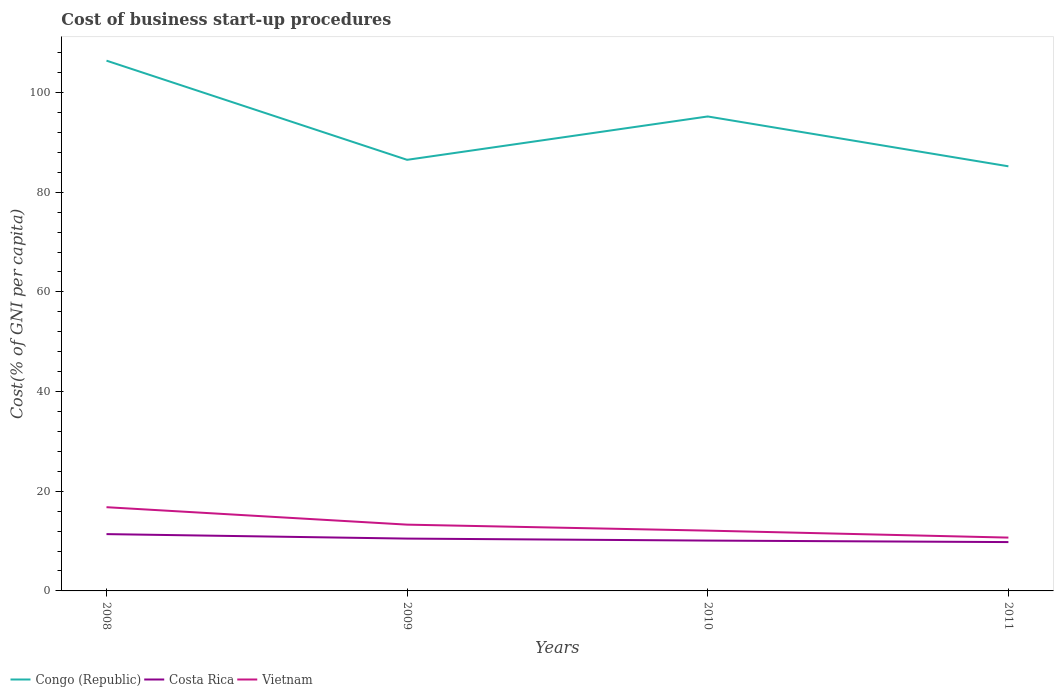Is the number of lines equal to the number of legend labels?
Provide a short and direct response. Yes. Across all years, what is the maximum cost of business start-up procedures in Congo (Republic)?
Provide a short and direct response. 85.2. In which year was the cost of business start-up procedures in Costa Rica maximum?
Ensure brevity in your answer.  2011. What is the total cost of business start-up procedures in Congo (Republic) in the graph?
Keep it short and to the point. 10. What is the difference between the highest and the second highest cost of business start-up procedures in Congo (Republic)?
Provide a succinct answer. 21.2. What is the difference between the highest and the lowest cost of business start-up procedures in Costa Rica?
Provide a short and direct response. 2. Is the cost of business start-up procedures in Vietnam strictly greater than the cost of business start-up procedures in Congo (Republic) over the years?
Your response must be concise. Yes. Are the values on the major ticks of Y-axis written in scientific E-notation?
Your response must be concise. No. Does the graph contain any zero values?
Your answer should be compact. No. How many legend labels are there?
Offer a terse response. 3. How are the legend labels stacked?
Your answer should be very brief. Horizontal. What is the title of the graph?
Offer a very short reply. Cost of business start-up procedures. Does "East Asia (developing only)" appear as one of the legend labels in the graph?
Ensure brevity in your answer.  No. What is the label or title of the X-axis?
Ensure brevity in your answer.  Years. What is the label or title of the Y-axis?
Offer a very short reply. Cost(% of GNI per capita). What is the Cost(% of GNI per capita) in Congo (Republic) in 2008?
Keep it short and to the point. 106.4. What is the Cost(% of GNI per capita) of Congo (Republic) in 2009?
Your answer should be very brief. 86.5. What is the Cost(% of GNI per capita) of Vietnam in 2009?
Your response must be concise. 13.3. What is the Cost(% of GNI per capita) of Congo (Republic) in 2010?
Ensure brevity in your answer.  95.2. What is the Cost(% of GNI per capita) of Congo (Republic) in 2011?
Provide a short and direct response. 85.2. Across all years, what is the maximum Cost(% of GNI per capita) of Congo (Republic)?
Offer a terse response. 106.4. Across all years, what is the maximum Cost(% of GNI per capita) of Vietnam?
Your response must be concise. 16.8. Across all years, what is the minimum Cost(% of GNI per capita) of Congo (Republic)?
Provide a succinct answer. 85.2. Across all years, what is the minimum Cost(% of GNI per capita) in Costa Rica?
Provide a succinct answer. 9.8. What is the total Cost(% of GNI per capita) in Congo (Republic) in the graph?
Ensure brevity in your answer.  373.3. What is the total Cost(% of GNI per capita) of Costa Rica in the graph?
Your answer should be very brief. 41.8. What is the total Cost(% of GNI per capita) of Vietnam in the graph?
Keep it short and to the point. 52.9. What is the difference between the Cost(% of GNI per capita) of Vietnam in 2008 and that in 2009?
Make the answer very short. 3.5. What is the difference between the Cost(% of GNI per capita) of Costa Rica in 2008 and that in 2010?
Give a very brief answer. 1.3. What is the difference between the Cost(% of GNI per capita) in Congo (Republic) in 2008 and that in 2011?
Ensure brevity in your answer.  21.2. What is the difference between the Cost(% of GNI per capita) in Vietnam in 2008 and that in 2011?
Ensure brevity in your answer.  6.1. What is the difference between the Cost(% of GNI per capita) in Costa Rica in 2009 and that in 2010?
Ensure brevity in your answer.  0.4. What is the difference between the Cost(% of GNI per capita) of Vietnam in 2009 and that in 2010?
Give a very brief answer. 1.2. What is the difference between the Cost(% of GNI per capita) of Congo (Republic) in 2009 and that in 2011?
Provide a succinct answer. 1.3. What is the difference between the Cost(% of GNI per capita) in Costa Rica in 2009 and that in 2011?
Ensure brevity in your answer.  0.7. What is the difference between the Cost(% of GNI per capita) of Congo (Republic) in 2010 and that in 2011?
Keep it short and to the point. 10. What is the difference between the Cost(% of GNI per capita) of Congo (Republic) in 2008 and the Cost(% of GNI per capita) of Costa Rica in 2009?
Provide a short and direct response. 95.9. What is the difference between the Cost(% of GNI per capita) of Congo (Republic) in 2008 and the Cost(% of GNI per capita) of Vietnam in 2009?
Give a very brief answer. 93.1. What is the difference between the Cost(% of GNI per capita) of Congo (Republic) in 2008 and the Cost(% of GNI per capita) of Costa Rica in 2010?
Your answer should be compact. 96.3. What is the difference between the Cost(% of GNI per capita) of Congo (Republic) in 2008 and the Cost(% of GNI per capita) of Vietnam in 2010?
Provide a succinct answer. 94.3. What is the difference between the Cost(% of GNI per capita) of Costa Rica in 2008 and the Cost(% of GNI per capita) of Vietnam in 2010?
Keep it short and to the point. -0.7. What is the difference between the Cost(% of GNI per capita) of Congo (Republic) in 2008 and the Cost(% of GNI per capita) of Costa Rica in 2011?
Make the answer very short. 96.6. What is the difference between the Cost(% of GNI per capita) in Congo (Republic) in 2008 and the Cost(% of GNI per capita) in Vietnam in 2011?
Your answer should be very brief. 95.7. What is the difference between the Cost(% of GNI per capita) of Congo (Republic) in 2009 and the Cost(% of GNI per capita) of Costa Rica in 2010?
Provide a short and direct response. 76.4. What is the difference between the Cost(% of GNI per capita) in Congo (Republic) in 2009 and the Cost(% of GNI per capita) in Vietnam in 2010?
Ensure brevity in your answer.  74.4. What is the difference between the Cost(% of GNI per capita) of Congo (Republic) in 2009 and the Cost(% of GNI per capita) of Costa Rica in 2011?
Keep it short and to the point. 76.7. What is the difference between the Cost(% of GNI per capita) of Congo (Republic) in 2009 and the Cost(% of GNI per capita) of Vietnam in 2011?
Provide a succinct answer. 75.8. What is the difference between the Cost(% of GNI per capita) of Congo (Republic) in 2010 and the Cost(% of GNI per capita) of Costa Rica in 2011?
Keep it short and to the point. 85.4. What is the difference between the Cost(% of GNI per capita) of Congo (Republic) in 2010 and the Cost(% of GNI per capita) of Vietnam in 2011?
Offer a very short reply. 84.5. What is the average Cost(% of GNI per capita) in Congo (Republic) per year?
Your answer should be very brief. 93.33. What is the average Cost(% of GNI per capita) in Costa Rica per year?
Make the answer very short. 10.45. What is the average Cost(% of GNI per capita) of Vietnam per year?
Give a very brief answer. 13.22. In the year 2008, what is the difference between the Cost(% of GNI per capita) in Congo (Republic) and Cost(% of GNI per capita) in Vietnam?
Offer a terse response. 89.6. In the year 2009, what is the difference between the Cost(% of GNI per capita) of Congo (Republic) and Cost(% of GNI per capita) of Vietnam?
Your answer should be compact. 73.2. In the year 2010, what is the difference between the Cost(% of GNI per capita) of Congo (Republic) and Cost(% of GNI per capita) of Costa Rica?
Your answer should be compact. 85.1. In the year 2010, what is the difference between the Cost(% of GNI per capita) of Congo (Republic) and Cost(% of GNI per capita) of Vietnam?
Keep it short and to the point. 83.1. In the year 2011, what is the difference between the Cost(% of GNI per capita) in Congo (Republic) and Cost(% of GNI per capita) in Costa Rica?
Make the answer very short. 75.4. In the year 2011, what is the difference between the Cost(% of GNI per capita) in Congo (Republic) and Cost(% of GNI per capita) in Vietnam?
Provide a succinct answer. 74.5. What is the ratio of the Cost(% of GNI per capita) of Congo (Republic) in 2008 to that in 2009?
Offer a terse response. 1.23. What is the ratio of the Cost(% of GNI per capita) of Costa Rica in 2008 to that in 2009?
Ensure brevity in your answer.  1.09. What is the ratio of the Cost(% of GNI per capita) in Vietnam in 2008 to that in 2009?
Give a very brief answer. 1.26. What is the ratio of the Cost(% of GNI per capita) in Congo (Republic) in 2008 to that in 2010?
Your response must be concise. 1.12. What is the ratio of the Cost(% of GNI per capita) in Costa Rica in 2008 to that in 2010?
Give a very brief answer. 1.13. What is the ratio of the Cost(% of GNI per capita) of Vietnam in 2008 to that in 2010?
Keep it short and to the point. 1.39. What is the ratio of the Cost(% of GNI per capita) in Congo (Republic) in 2008 to that in 2011?
Ensure brevity in your answer.  1.25. What is the ratio of the Cost(% of GNI per capita) of Costa Rica in 2008 to that in 2011?
Ensure brevity in your answer.  1.16. What is the ratio of the Cost(% of GNI per capita) of Vietnam in 2008 to that in 2011?
Provide a succinct answer. 1.57. What is the ratio of the Cost(% of GNI per capita) in Congo (Republic) in 2009 to that in 2010?
Offer a very short reply. 0.91. What is the ratio of the Cost(% of GNI per capita) in Costa Rica in 2009 to that in 2010?
Offer a very short reply. 1.04. What is the ratio of the Cost(% of GNI per capita) in Vietnam in 2009 to that in 2010?
Offer a very short reply. 1.1. What is the ratio of the Cost(% of GNI per capita) of Congo (Republic) in 2009 to that in 2011?
Offer a terse response. 1.02. What is the ratio of the Cost(% of GNI per capita) in Costa Rica in 2009 to that in 2011?
Keep it short and to the point. 1.07. What is the ratio of the Cost(% of GNI per capita) of Vietnam in 2009 to that in 2011?
Provide a succinct answer. 1.24. What is the ratio of the Cost(% of GNI per capita) of Congo (Republic) in 2010 to that in 2011?
Keep it short and to the point. 1.12. What is the ratio of the Cost(% of GNI per capita) in Costa Rica in 2010 to that in 2011?
Give a very brief answer. 1.03. What is the ratio of the Cost(% of GNI per capita) in Vietnam in 2010 to that in 2011?
Your response must be concise. 1.13. What is the difference between the highest and the second highest Cost(% of GNI per capita) of Congo (Republic)?
Provide a short and direct response. 11.2. What is the difference between the highest and the second highest Cost(% of GNI per capita) in Vietnam?
Keep it short and to the point. 3.5. What is the difference between the highest and the lowest Cost(% of GNI per capita) in Congo (Republic)?
Provide a succinct answer. 21.2. 